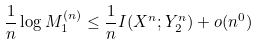Convert formula to latex. <formula><loc_0><loc_0><loc_500><loc_500>\frac { 1 } { n } \log M _ { 1 } ^ { ( n ) } \leq \frac { 1 } { n } I ( X ^ { n } ; Y _ { 2 } ^ { n } ) + o ( n ^ { 0 } )</formula> 